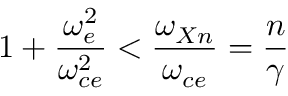<formula> <loc_0><loc_0><loc_500><loc_500>1 + \frac { \omega _ { e } ^ { 2 } } { \omega _ { c e } ^ { 2 } } < \frac { \omega _ { X n } } { \omega _ { c e } } = \frac { n } { \gamma }</formula> 